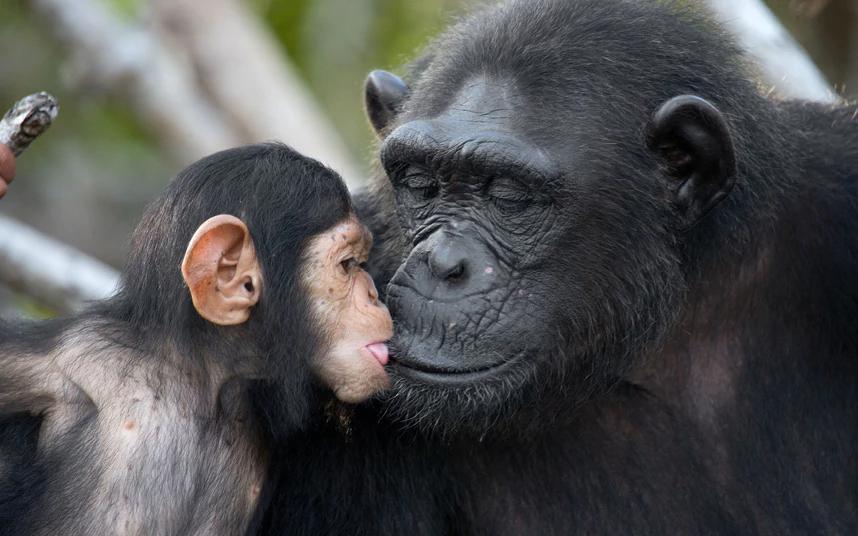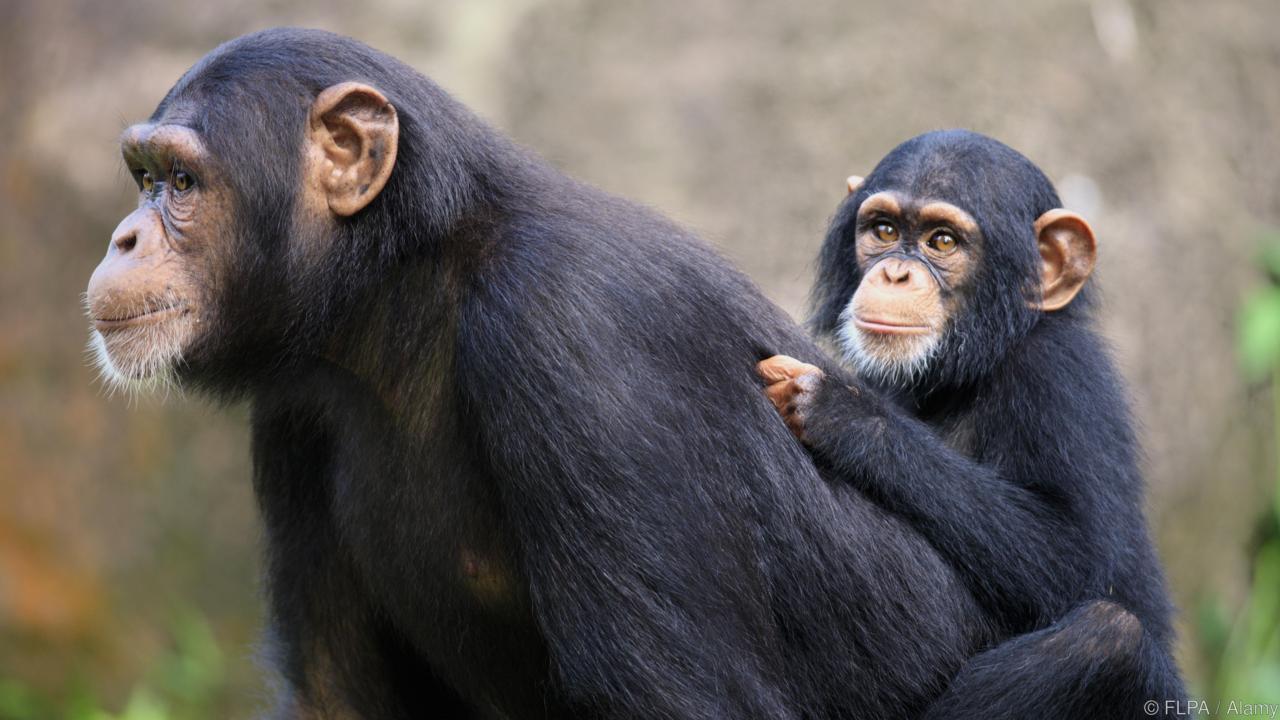The first image is the image on the left, the second image is the image on the right. For the images displayed, is the sentence "The is one monkey in the image on the right." factually correct? Answer yes or no. No. 